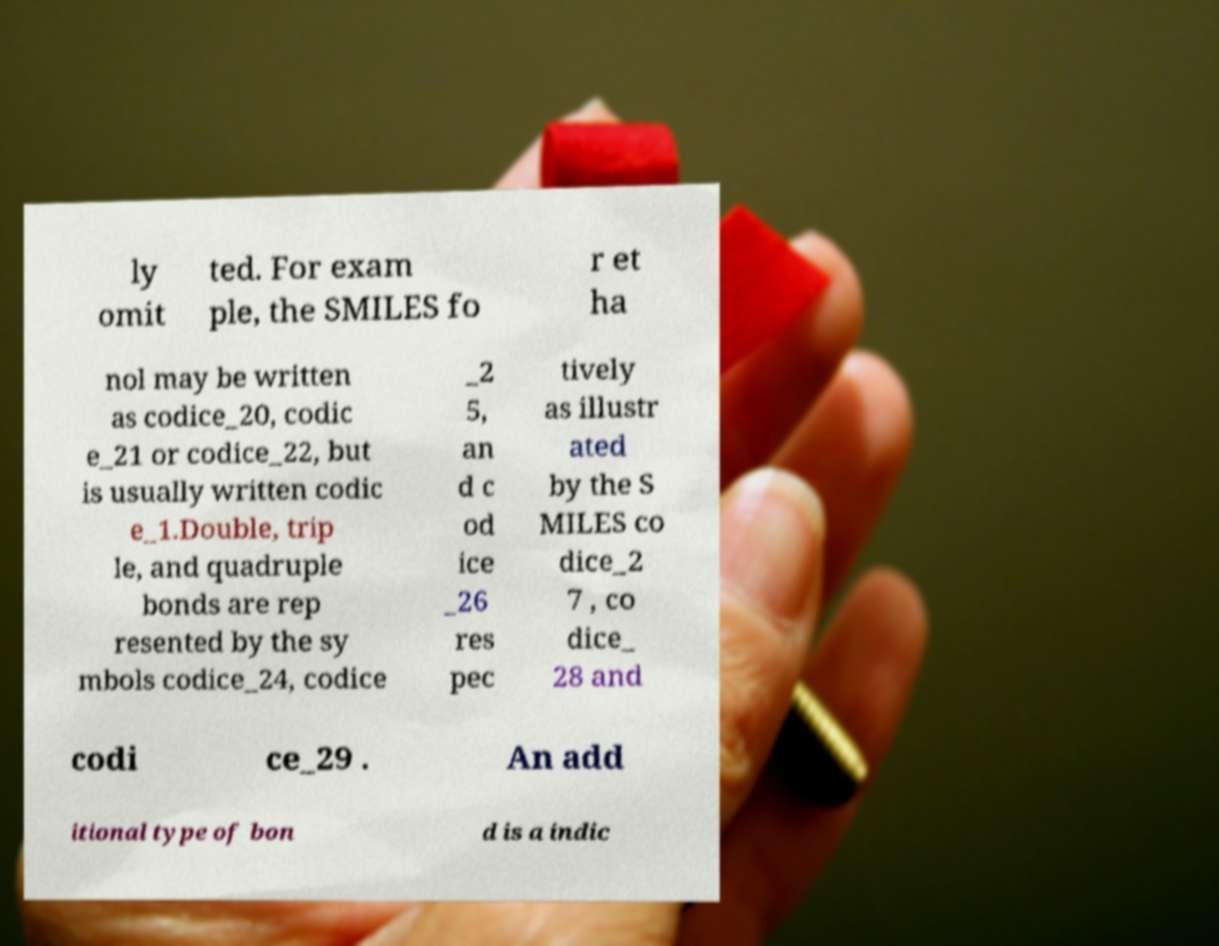Please read and relay the text visible in this image. What does it say? ly omit ted. For exam ple, the SMILES fo r et ha nol may be written as codice_20, codic e_21 or codice_22, but is usually written codic e_1.Double, trip le, and quadruple bonds are rep resented by the sy mbols codice_24, codice _2 5, an d c od ice _26 res pec tively as illustr ated by the S MILES co dice_2 7 , co dice_ 28 and codi ce_29 . An add itional type of bon d is a indic 